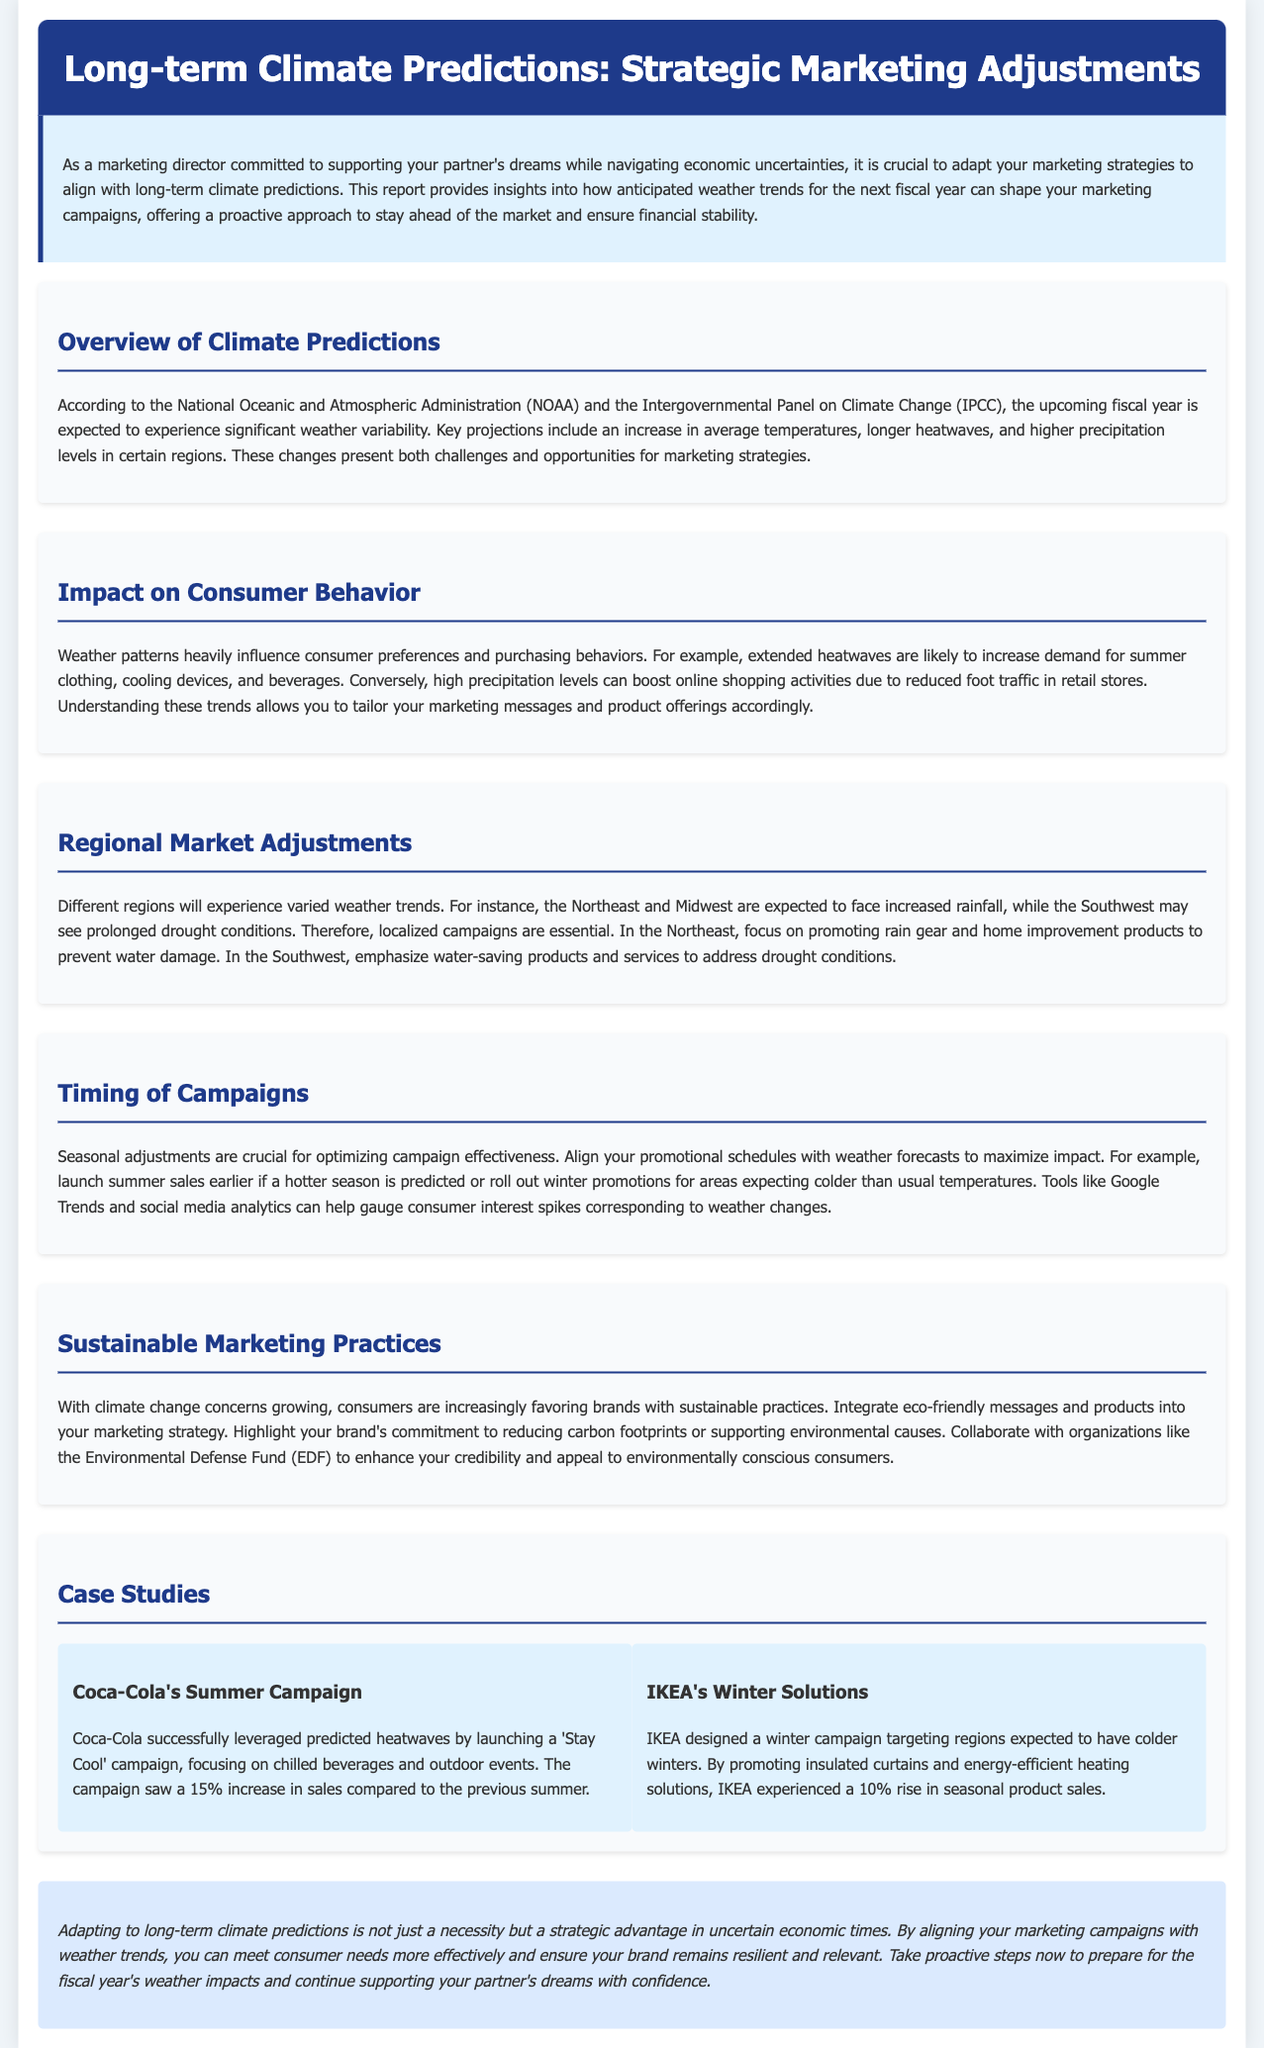What is the predicted weather variability for the next fiscal year? The document states that significant weather variability is expected for the upcoming fiscal year.
Answer: significant weather variability Which regions are expected to face increased rainfall? The document specifies that the Northeast and Midwest are expected to experience increased rainfall.
Answer: Northeast and Midwest What product category is likely to see increased demand due to extended heatwaves? The document indicates that summer clothing is likely to see increased demand due to extended heatwaves.
Answer: summer clothing How much did Coca-Cola's summer campaign increase sales by? The document mentions that Coca-Cola's campaign saw a 15% increase in sales compared to the previous summer.
Answer: 15% What can be emphasized in campaigns for the Southwest region? The document recommends emphasizing water-saving products and services for the Southwest due to drought conditions.
Answer: water-saving products What should you align your promotional schedules with? The document advises aligning promotional schedules with weather forecasts to maximize impact.
Answer: weather forecasts What season's sales might be launched earlier if a hotter season is predicted? According to the document, summer sales might be launched earlier if a hotter season is predicted.
Answer: summer sales What is a growing concern in marketing practices mentioned in the document? The document highlights that climate change concerns are a growing issue in marketing practices.
Answer: climate change What increase in sales did IKEA experience with its winter solutions campaign? The document states that IKEA experienced a 10% rise in seasonal product sales.
Answer: 10% 